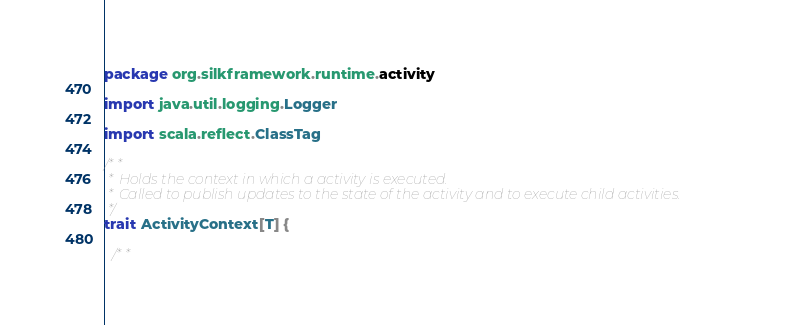Convert code to text. <code><loc_0><loc_0><loc_500><loc_500><_Scala_>package org.silkframework.runtime.activity

import java.util.logging.Logger

import scala.reflect.ClassTag

/**
 * Holds the context in which a activity is executed.
 * Called to publish updates to the state of the activity and to execute child activities.
 */
trait ActivityContext[T] {

  /**</code> 